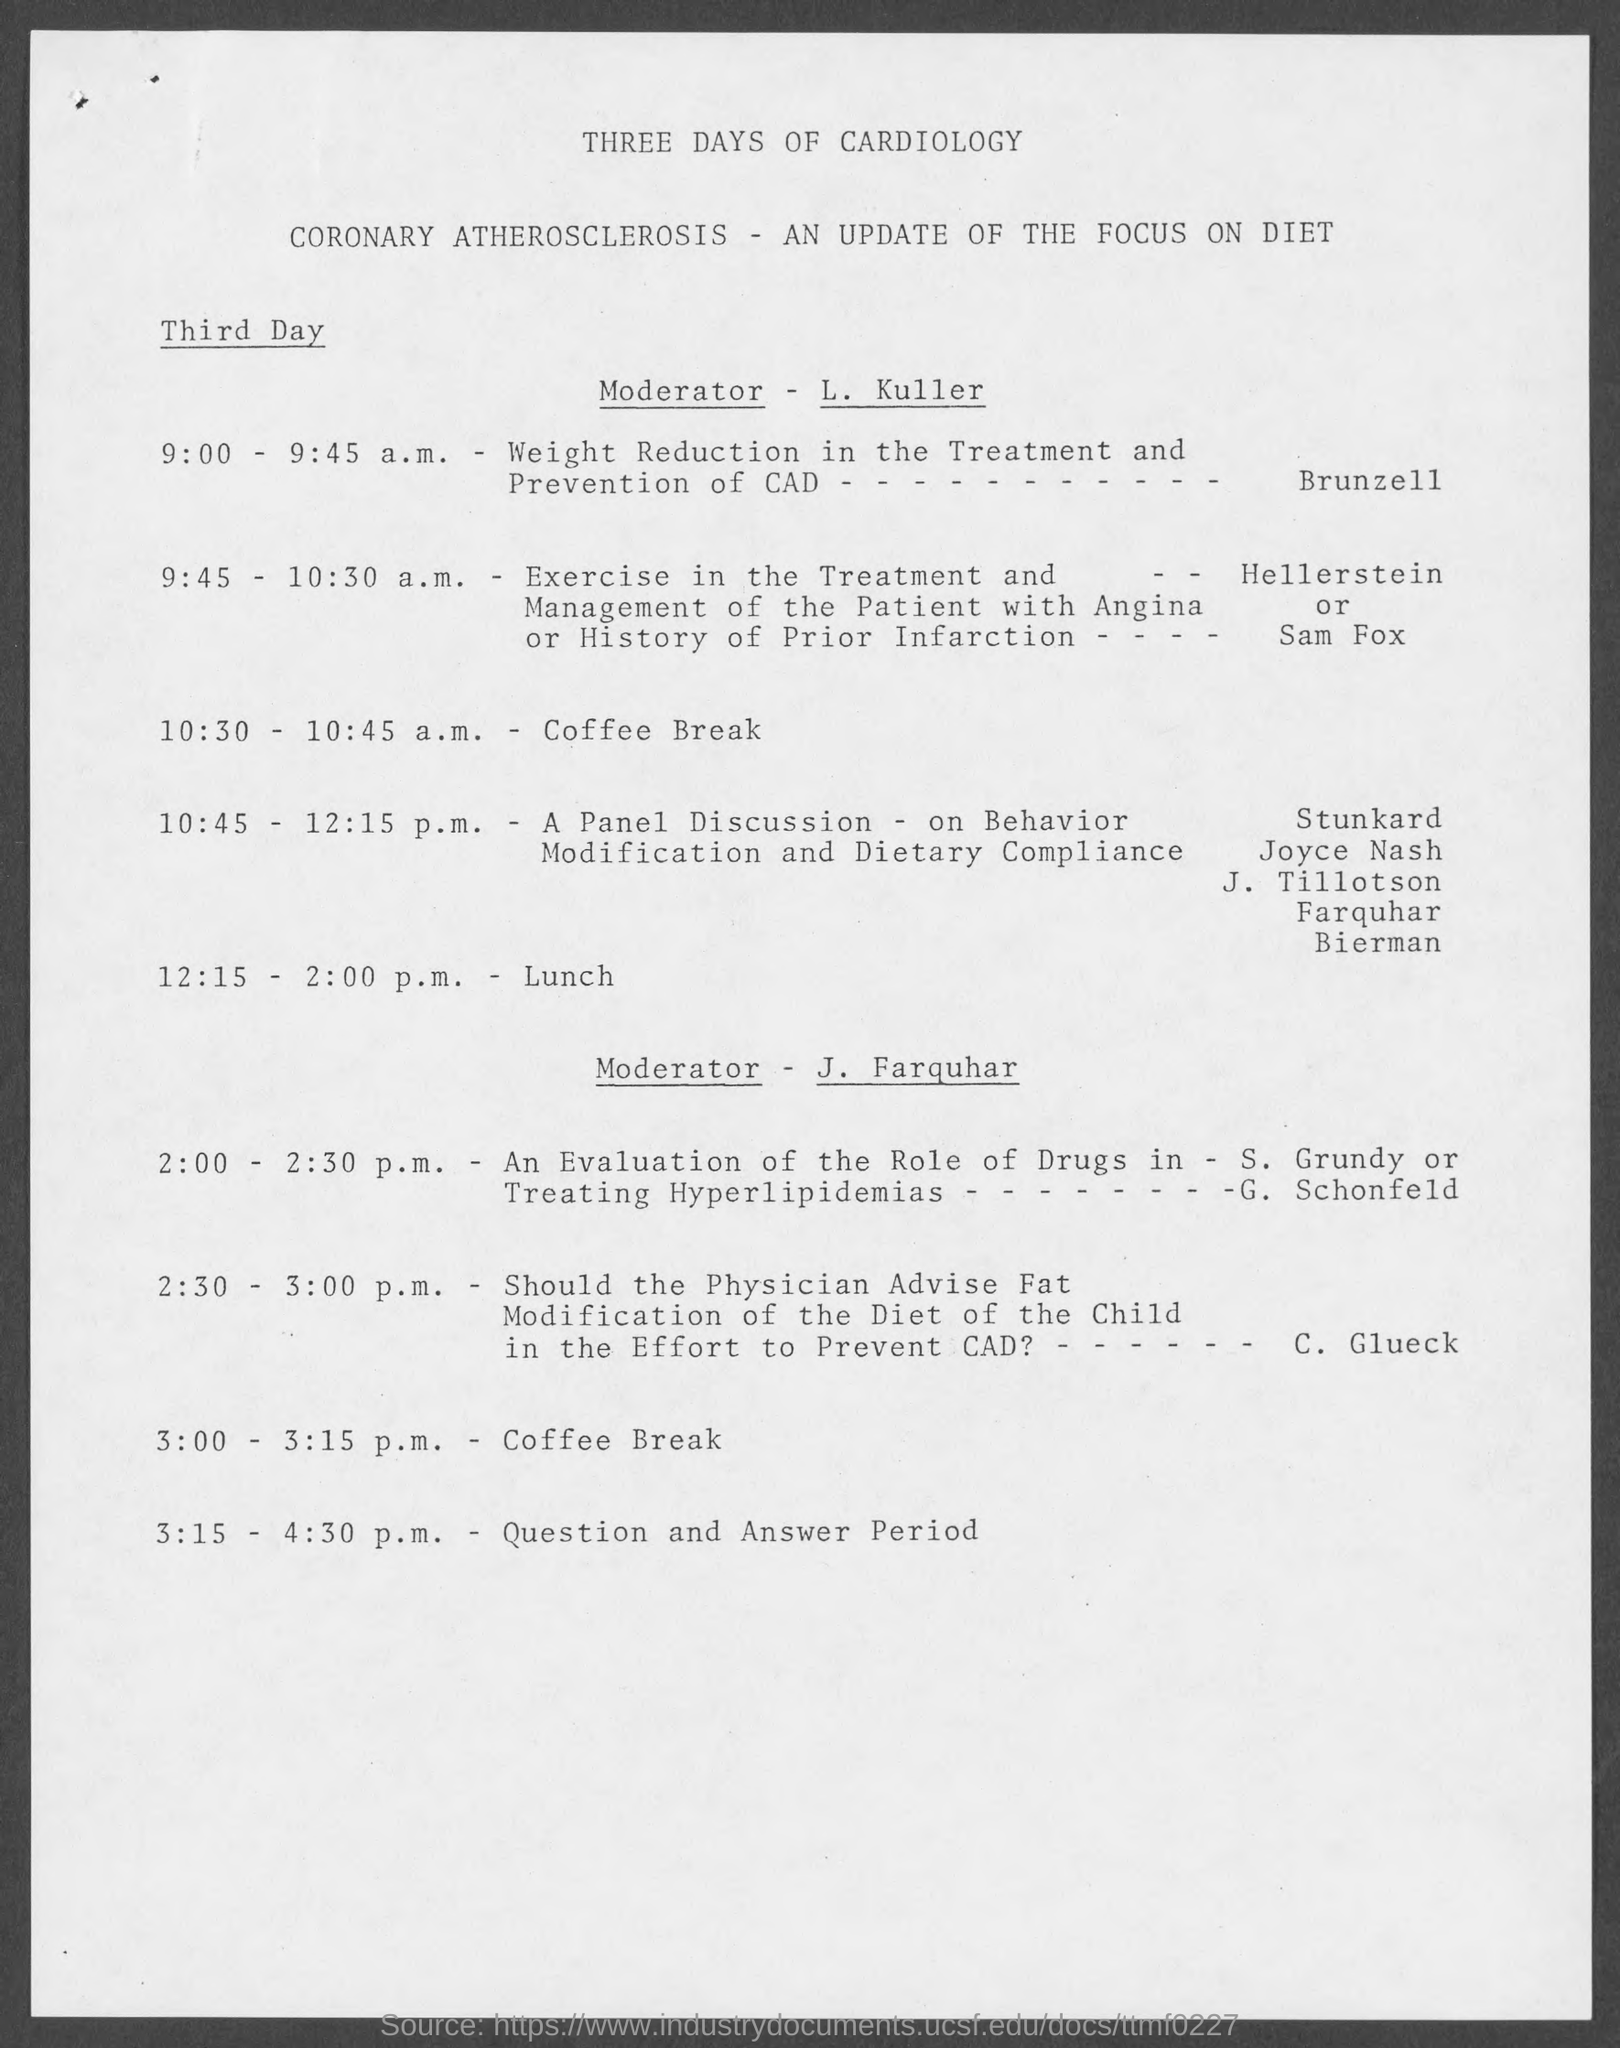Point out several critical features in this image. The coffee break will take place from 10:30 to 10:45. The lunch will take place from 12:15 to 2:00. 